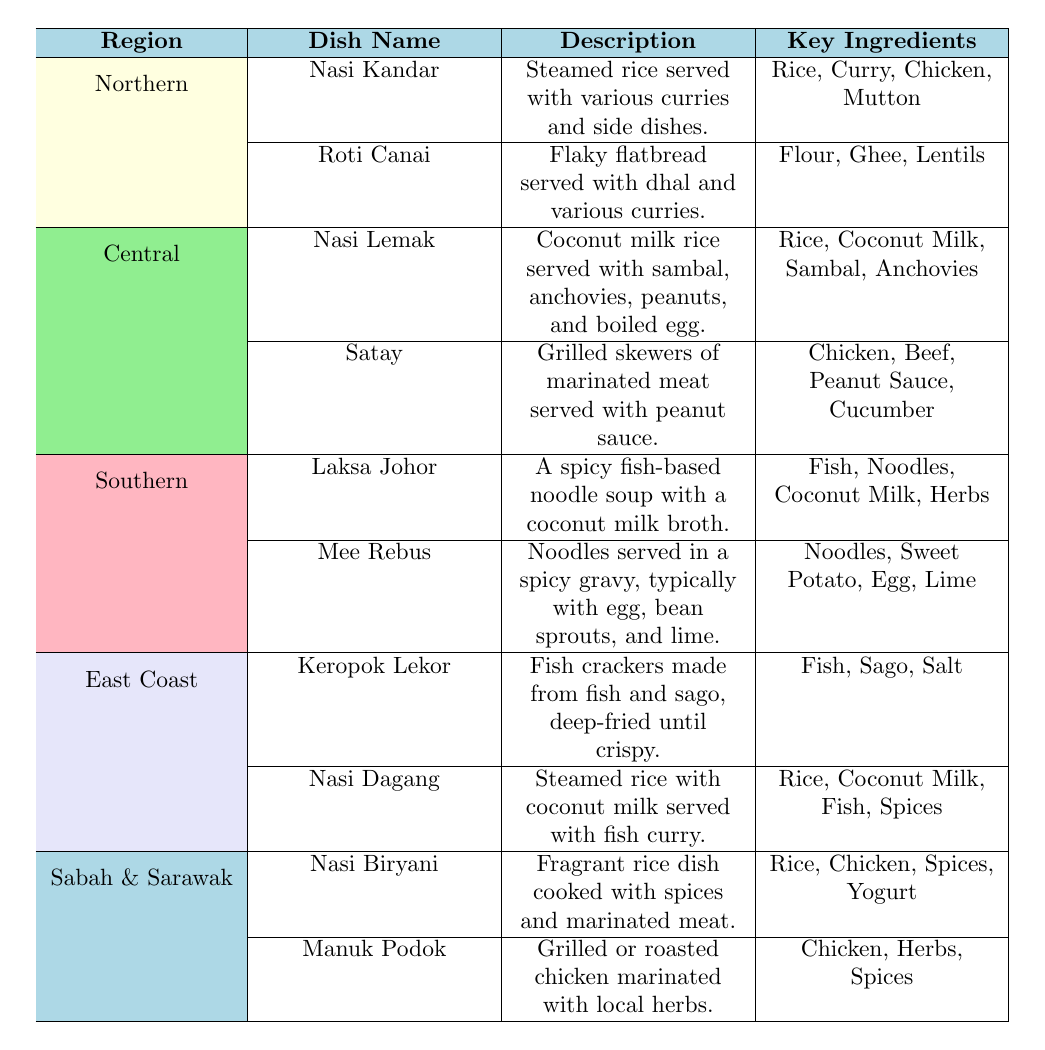What are the key ingredients of Nasi Kandar? The table lists Nasi Kandar in the Northern region and provides the key ingredients alongside it. The ingredients listed are Rice, Curry, Chicken, and Mutton.
Answer: Rice, Curry, Chicken, Mutton Which dish from the Central region includes peanuts as a key ingredient? Looking at the Central region's dishes, Nasi Lemak and Satay are listed. Checking their key ingredients, Nasi Lemak has Sambal, Anchovies, and Peanuts; while Satay has Peanut Sauce. Therefore, Satay is the dish that includes peanuts specifically.
Answer: Satay Are there any dishes in the Southern region that contain coconut milk? The Southern region includes Laksa Johor and Mee Rebus. Looking at their key ingredients, Laksa Johor contains Coconut Milk, while Mee Rebus does not. Thus, there is one dish that contains coconut milk.
Answer: Yes Which region features a dish with fish and sago as key ingredients? The East Coast region has two dishes: Keropok Lekor and Nasi Dagang. Keropok Lekor's key ingredients include Fish and Sago, confirming that this dish qualifies based on the question.
Answer: East Coast How many dishes in the Sabah & Sarawak region include rice as a key ingredient? The dishes listed in the Sabah & Sarawak region are Nasi Biryani and Manuk Podok. Checking their key ingredients, Nasi Biryani includes Rice, while Manuk Podok does not. Therefore, counting the dish that contains rice, we find there is only one.
Answer: 1 What is the total number of dishes presented from the Northern and Central regions combined? The Northern region has 2 dishes (Nasi Kandar and Roti Canai), and the Central region also has 2 dishes (Nasi Lemak and Satay). Adding these together gives 2 + 2 = 4.
Answer: 4 Is Laksa Johor served with noodles? The description of Laksa Johor indicates it is a spicy fish-based noodle soup, which confirms that it is indeed served with noodles.
Answer: Yes Which dish has a description that includes being deep-fried until crispy? Looking through the table, Keropok Lekor has a description that states it’s made from fish and sago, deep-fried until crispy.
Answer: Keropok Lekor 